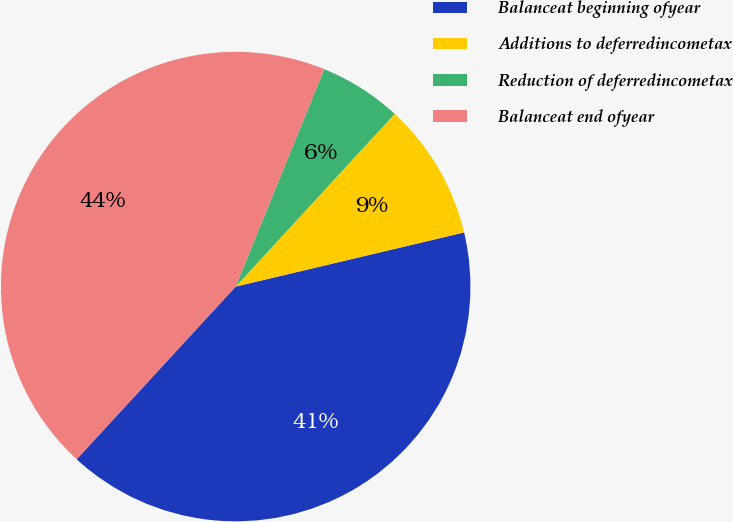<chart> <loc_0><loc_0><loc_500><loc_500><pie_chart><fcel>Balanceat beginning ofyear<fcel>Additions to deferredincometax<fcel>Reduction of deferredincometax<fcel>Balanceat end ofyear<nl><fcel>40.55%<fcel>9.45%<fcel>5.69%<fcel>44.31%<nl></chart> 